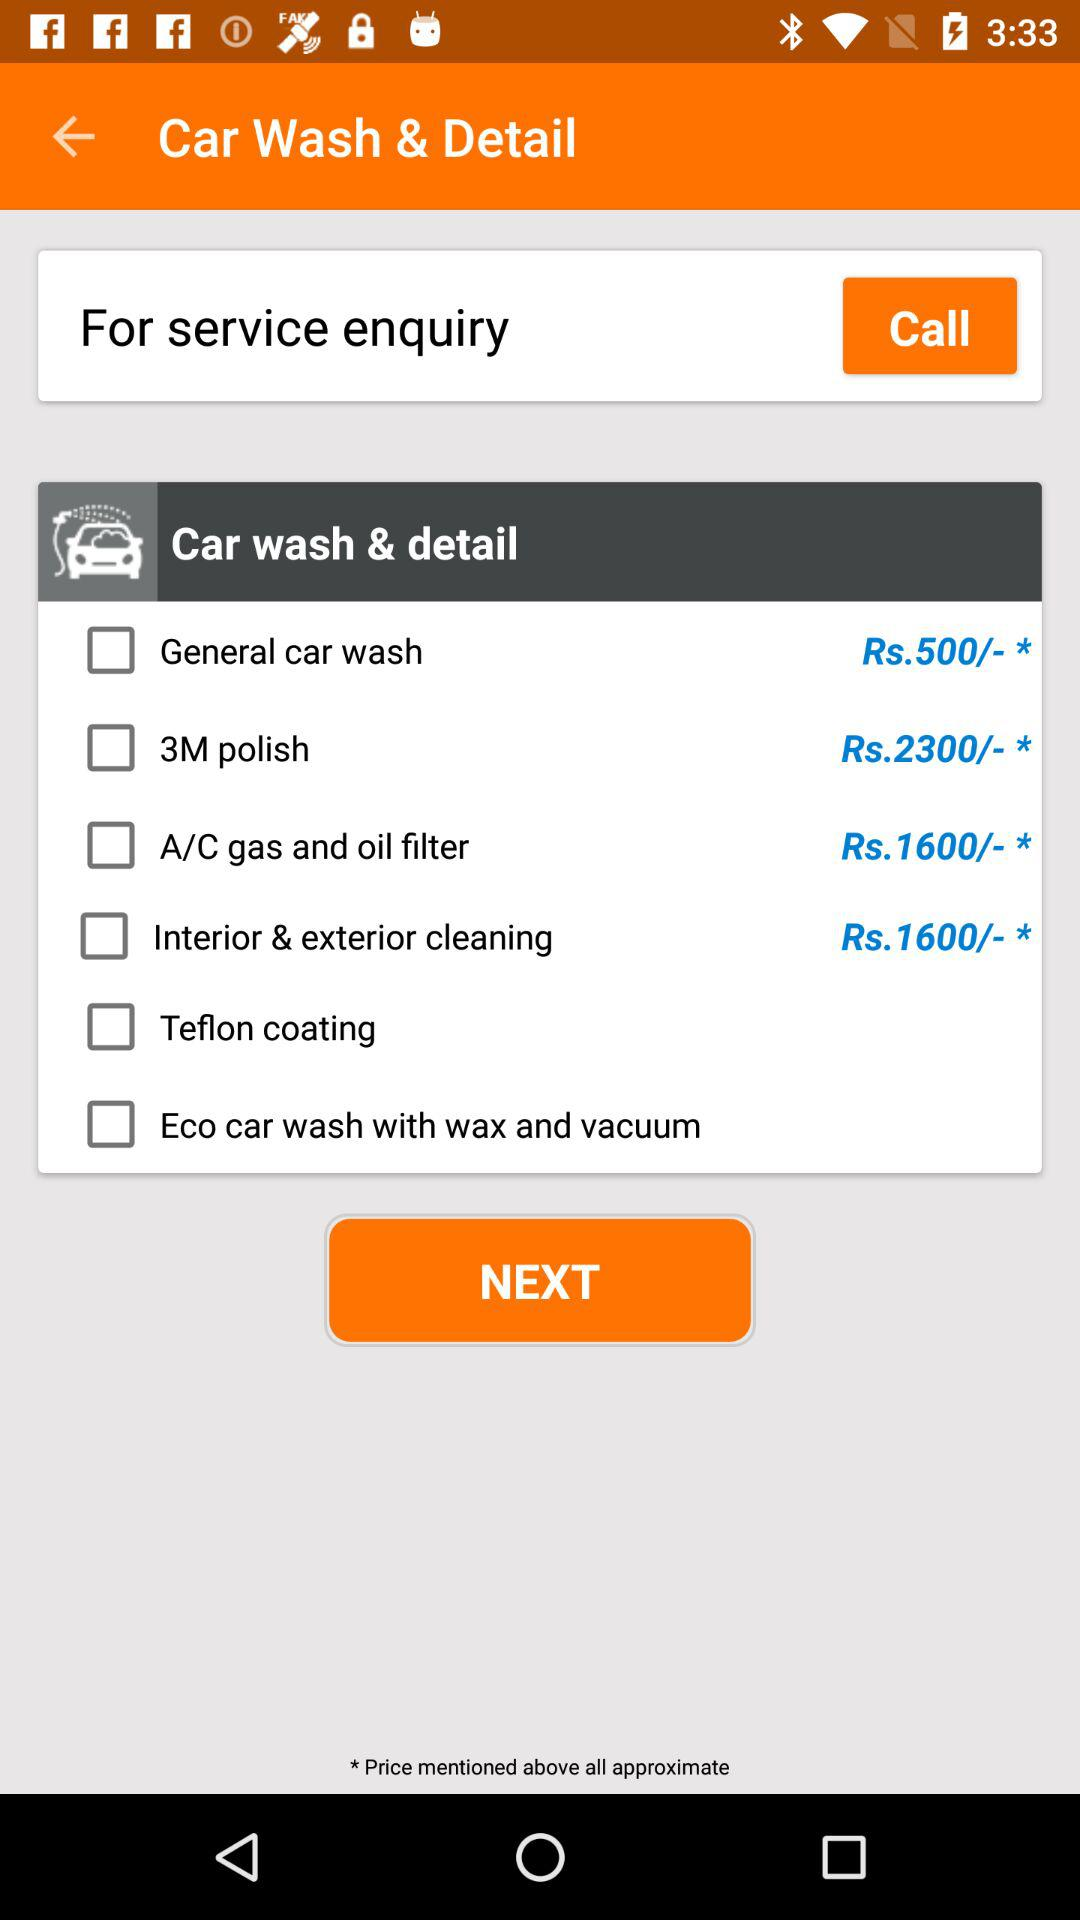What is the status of "Teflon coating"? The status is "off". 